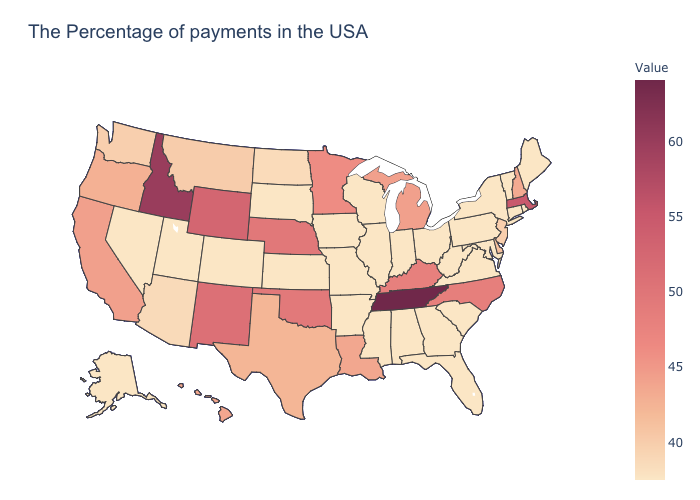Which states hav the highest value in the South?
Quick response, please. Tennessee. Does Kentucky have a higher value than Ohio?
Give a very brief answer. Yes. Does Virginia have the lowest value in the USA?
Give a very brief answer. Yes. Which states have the lowest value in the South?
Keep it brief. Maryland, Virginia, South Carolina, West Virginia, Florida, Georgia, Alabama, Mississippi, Arkansas. Does Rhode Island have the lowest value in the Northeast?
Quick response, please. Yes. Which states have the lowest value in the South?
Short answer required. Maryland, Virginia, South Carolina, West Virginia, Florida, Georgia, Alabama, Mississippi, Arkansas. Does Idaho have the highest value in the West?
Answer briefly. Yes. Among the states that border Idaho , which have the highest value?
Be succinct. Wyoming. 